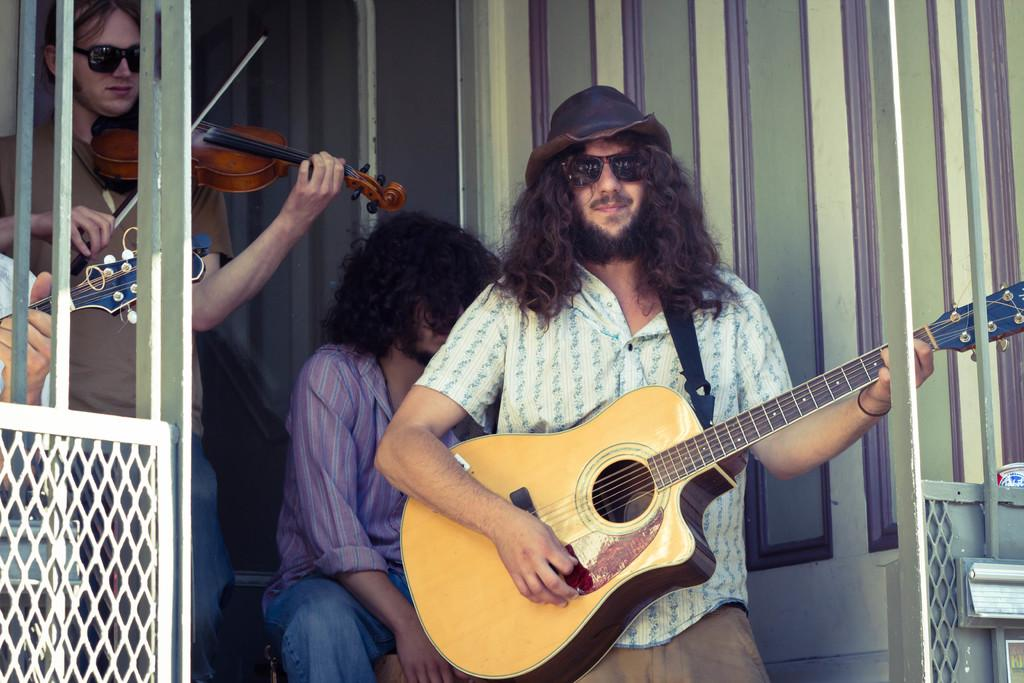How many people are in the image? There are three persons in the image. What are two of the persons doing? Two of the persons are holding musical instruments. What is the position of the third person? One person is sitting. What can be seen in the background of the image? There is a wall in the background of the image. What type of cap can be seen on the head of the person playing the guitar? There is no cap visible on the head of any person in the image. What kind of waste is being disposed of in the image? There is no waste disposal activity depicted in the image. 